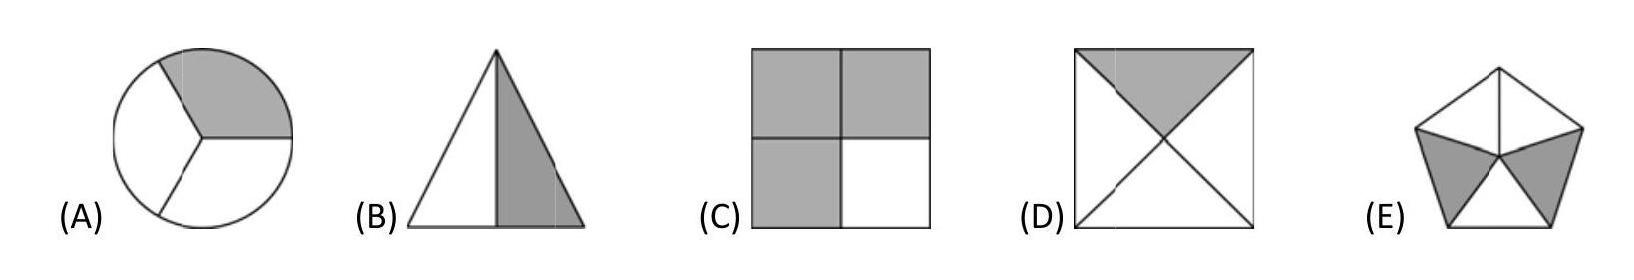In which shape is exactly one half coloured grey?
Choices: ['A', 'B', 'C', 'D', 'E'] Answer is B. 